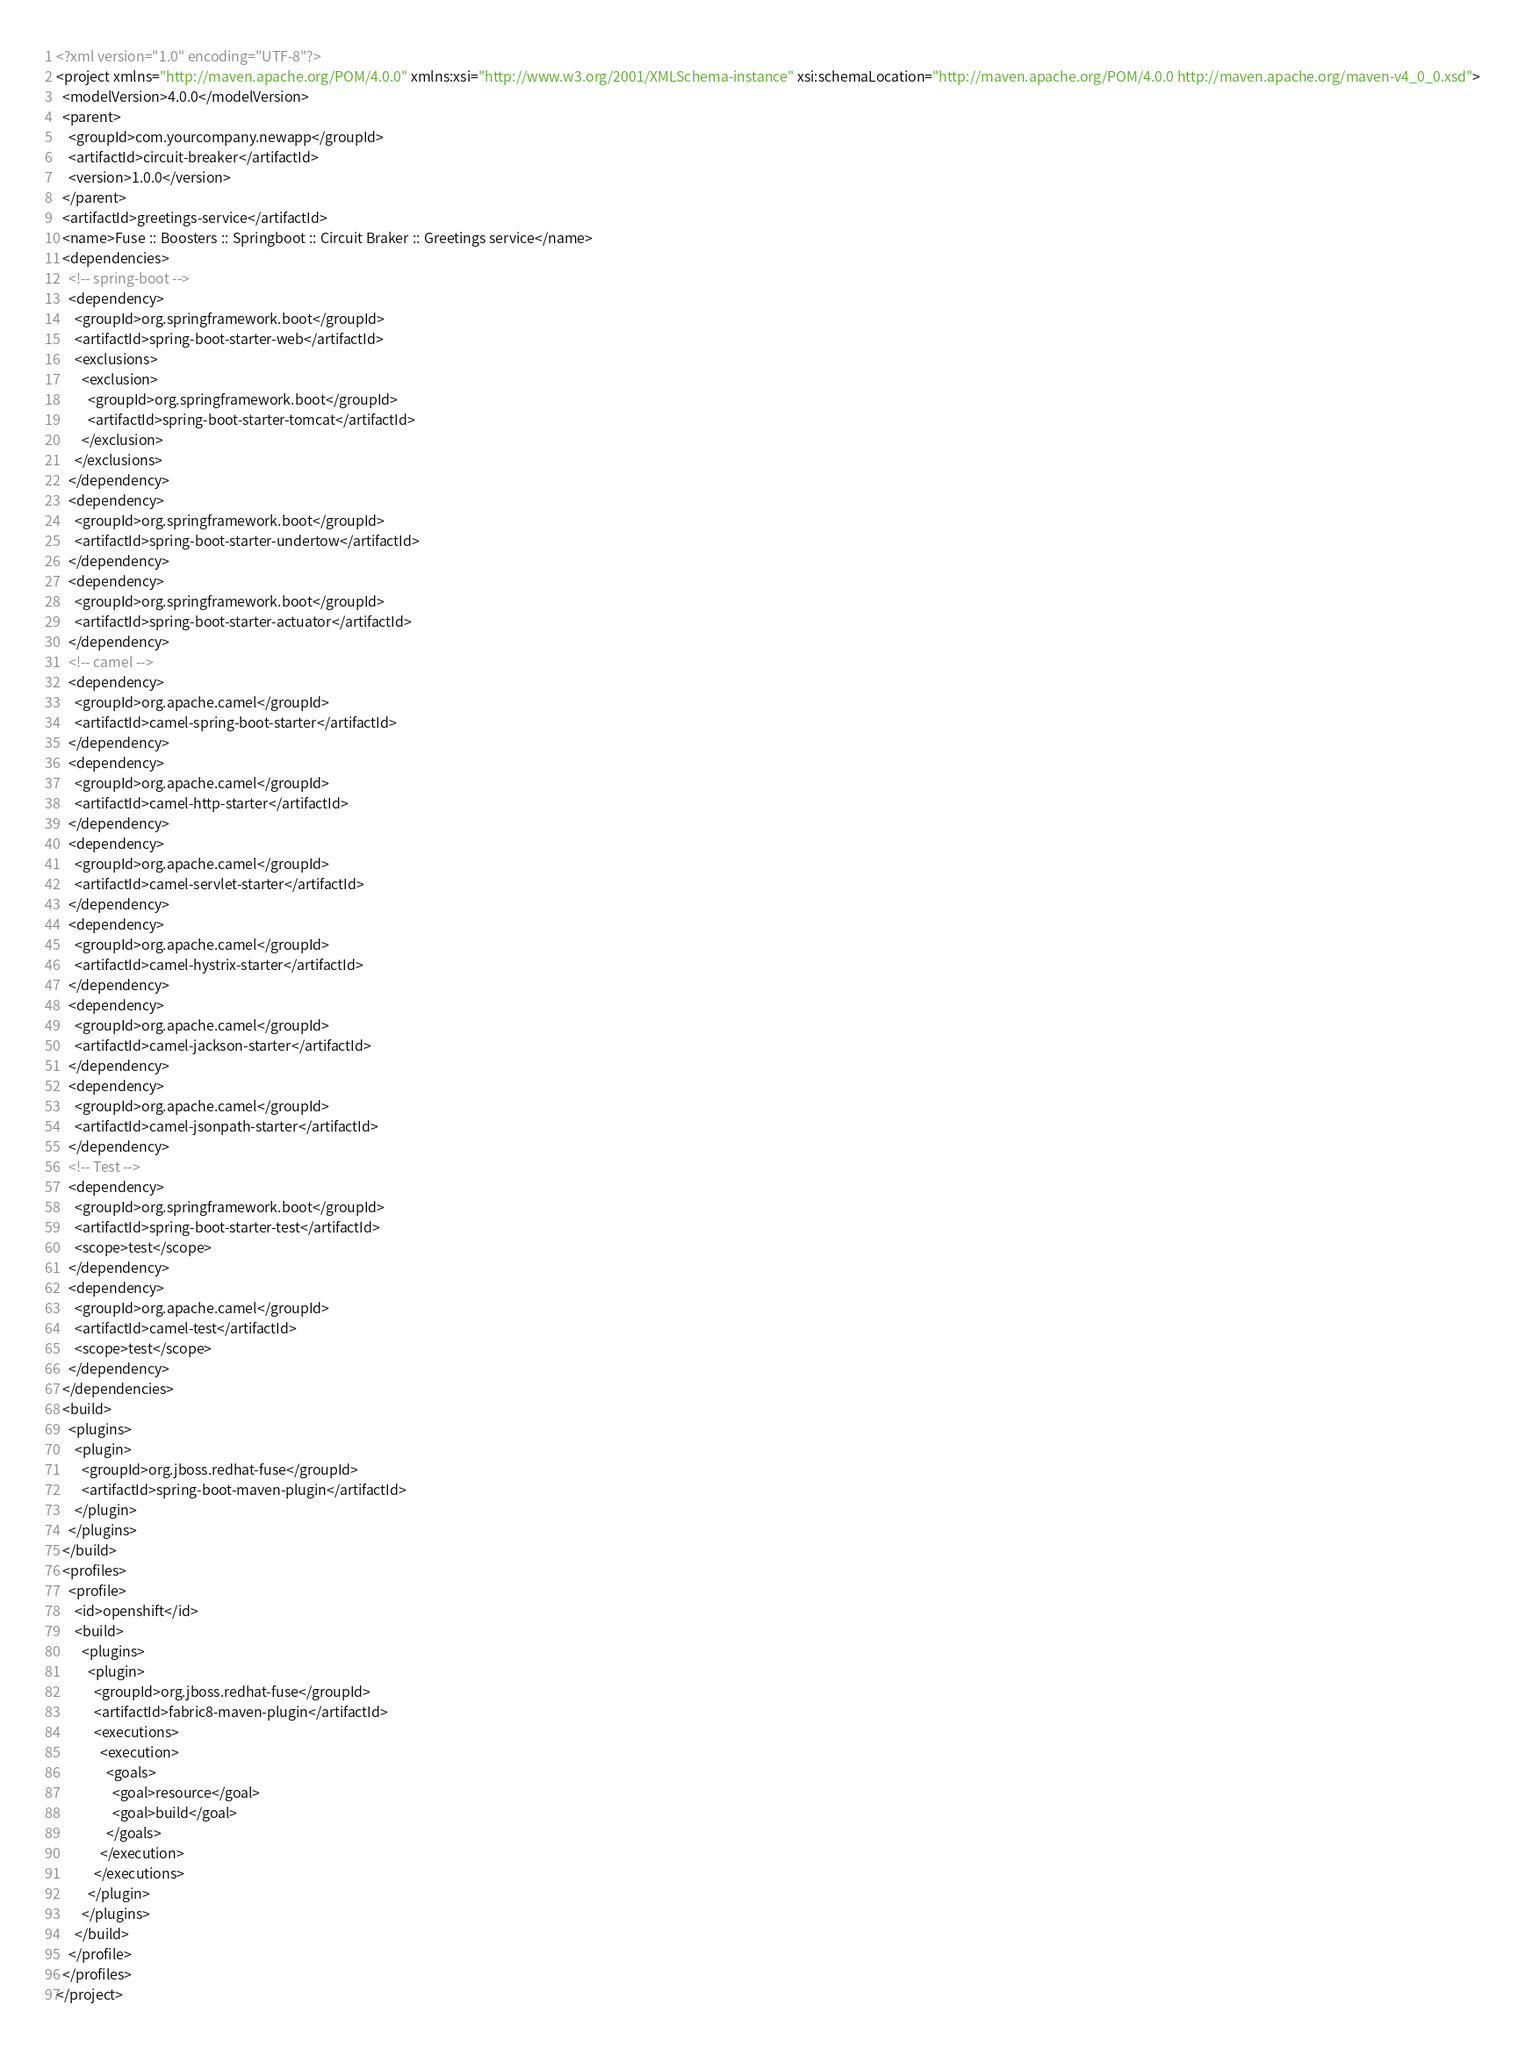<code> <loc_0><loc_0><loc_500><loc_500><_XML_><?xml version="1.0" encoding="UTF-8"?>
<project xmlns="http://maven.apache.org/POM/4.0.0" xmlns:xsi="http://www.w3.org/2001/XMLSchema-instance" xsi:schemaLocation="http://maven.apache.org/POM/4.0.0 http://maven.apache.org/maven-v4_0_0.xsd">
  <modelVersion>4.0.0</modelVersion>
  <parent>
    <groupId>com.yourcompany.newapp</groupId>
    <artifactId>circuit-breaker</artifactId>
    <version>1.0.0</version>
  </parent>
  <artifactId>greetings-service</artifactId>
  <name>Fuse :: Boosters :: Springboot :: Circuit Braker :: Greetings service</name>
  <dependencies>
    <!-- spring-boot -->
    <dependency>
      <groupId>org.springframework.boot</groupId>
      <artifactId>spring-boot-starter-web</artifactId>
      <exclusions>
        <exclusion>
          <groupId>org.springframework.boot</groupId>
          <artifactId>spring-boot-starter-tomcat</artifactId>
        </exclusion>
      </exclusions>
    </dependency>
    <dependency>
      <groupId>org.springframework.boot</groupId>
      <artifactId>spring-boot-starter-undertow</artifactId>
    </dependency>
    <dependency>
      <groupId>org.springframework.boot</groupId>
      <artifactId>spring-boot-starter-actuator</artifactId>
    </dependency>
    <!-- camel -->
    <dependency>
      <groupId>org.apache.camel</groupId>
      <artifactId>camel-spring-boot-starter</artifactId>
    </dependency>
    <dependency>
      <groupId>org.apache.camel</groupId>
      <artifactId>camel-http-starter</artifactId>
    </dependency>
    <dependency>
      <groupId>org.apache.camel</groupId>
      <artifactId>camel-servlet-starter</artifactId>
    </dependency>
    <dependency>
      <groupId>org.apache.camel</groupId>
      <artifactId>camel-hystrix-starter</artifactId>
    </dependency>
    <dependency>
      <groupId>org.apache.camel</groupId>
      <artifactId>camel-jackson-starter</artifactId>
    </dependency>
    <dependency>
      <groupId>org.apache.camel</groupId>
      <artifactId>camel-jsonpath-starter</artifactId>
    </dependency>
    <!-- Test -->
    <dependency>
      <groupId>org.springframework.boot</groupId>
      <artifactId>spring-boot-starter-test</artifactId>
      <scope>test</scope>
    </dependency>
    <dependency>
      <groupId>org.apache.camel</groupId>
      <artifactId>camel-test</artifactId>
      <scope>test</scope>
    </dependency>
  </dependencies>
  <build>
    <plugins>
      <plugin>
        <groupId>org.jboss.redhat-fuse</groupId>
        <artifactId>spring-boot-maven-plugin</artifactId>
      </plugin>
    </plugins>
  </build>
  <profiles>
    <profile>
      <id>openshift</id>
      <build>
        <plugins>
          <plugin>
            <groupId>org.jboss.redhat-fuse</groupId>
            <artifactId>fabric8-maven-plugin</artifactId>
            <executions>
              <execution>
                <goals>
                  <goal>resource</goal>
                  <goal>build</goal>
                </goals>
              </execution>
            </executions>
          </plugin>
        </plugins>
      </build>
    </profile>
  </profiles>
</project>

</code> 